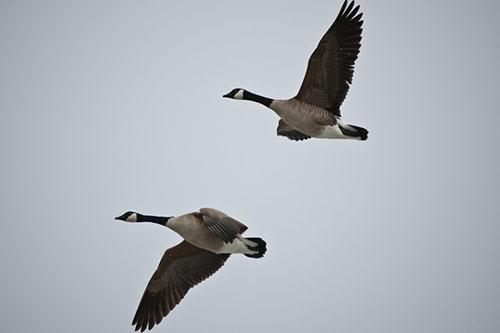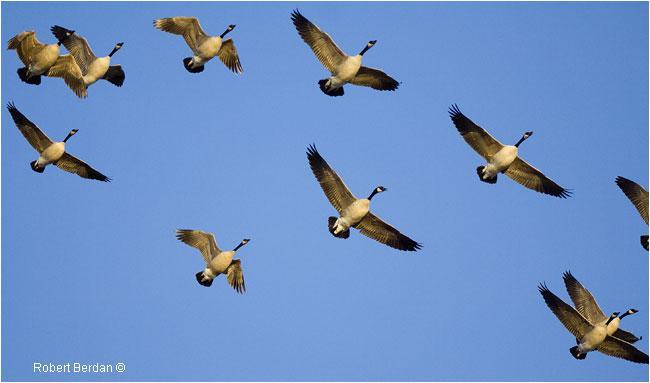The first image is the image on the left, the second image is the image on the right. Assess this claim about the two images: "The right image contains more birds than the left image.". Correct or not? Answer yes or no. Yes. 